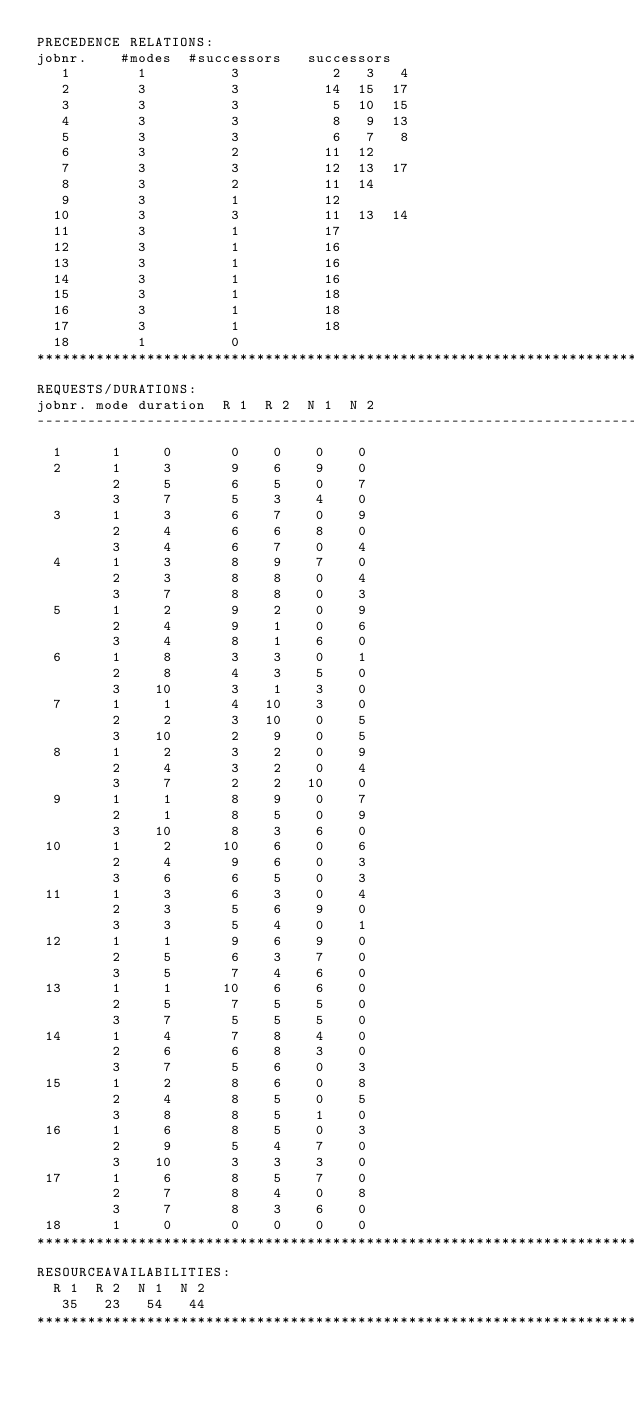<code> <loc_0><loc_0><loc_500><loc_500><_ObjectiveC_>PRECEDENCE RELATIONS:
jobnr.    #modes  #successors   successors
   1        1          3           2   3   4
   2        3          3          14  15  17
   3        3          3           5  10  15
   4        3          3           8   9  13
   5        3          3           6   7   8
   6        3          2          11  12
   7        3          3          12  13  17
   8        3          2          11  14
   9        3          1          12
  10        3          3          11  13  14
  11        3          1          17
  12        3          1          16
  13        3          1          16
  14        3          1          16
  15        3          1          18
  16        3          1          18
  17        3          1          18
  18        1          0        
************************************************************************
REQUESTS/DURATIONS:
jobnr. mode duration  R 1  R 2  N 1  N 2
------------------------------------------------------------------------
  1      1     0       0    0    0    0
  2      1     3       9    6    9    0
         2     5       6    5    0    7
         3     7       5    3    4    0
  3      1     3       6    7    0    9
         2     4       6    6    8    0
         3     4       6    7    0    4
  4      1     3       8    9    7    0
         2     3       8    8    0    4
         3     7       8    8    0    3
  5      1     2       9    2    0    9
         2     4       9    1    0    6
         3     4       8    1    6    0
  6      1     8       3    3    0    1
         2     8       4    3    5    0
         3    10       3    1    3    0
  7      1     1       4   10    3    0
         2     2       3   10    0    5
         3    10       2    9    0    5
  8      1     2       3    2    0    9
         2     4       3    2    0    4
         3     7       2    2   10    0
  9      1     1       8    9    0    7
         2     1       8    5    0    9
         3    10       8    3    6    0
 10      1     2      10    6    0    6
         2     4       9    6    0    3
         3     6       6    5    0    3
 11      1     3       6    3    0    4
         2     3       5    6    9    0
         3     3       5    4    0    1
 12      1     1       9    6    9    0
         2     5       6    3    7    0
         3     5       7    4    6    0
 13      1     1      10    6    6    0
         2     5       7    5    5    0
         3     7       5    5    5    0
 14      1     4       7    8    4    0
         2     6       6    8    3    0
         3     7       5    6    0    3
 15      1     2       8    6    0    8
         2     4       8    5    0    5
         3     8       8    5    1    0
 16      1     6       8    5    0    3
         2     9       5    4    7    0
         3    10       3    3    3    0
 17      1     6       8    5    7    0
         2     7       8    4    0    8
         3     7       8    3    6    0
 18      1     0       0    0    0    0
************************************************************************
RESOURCEAVAILABILITIES:
  R 1  R 2  N 1  N 2
   35   23   54   44
************************************************************************
</code> 